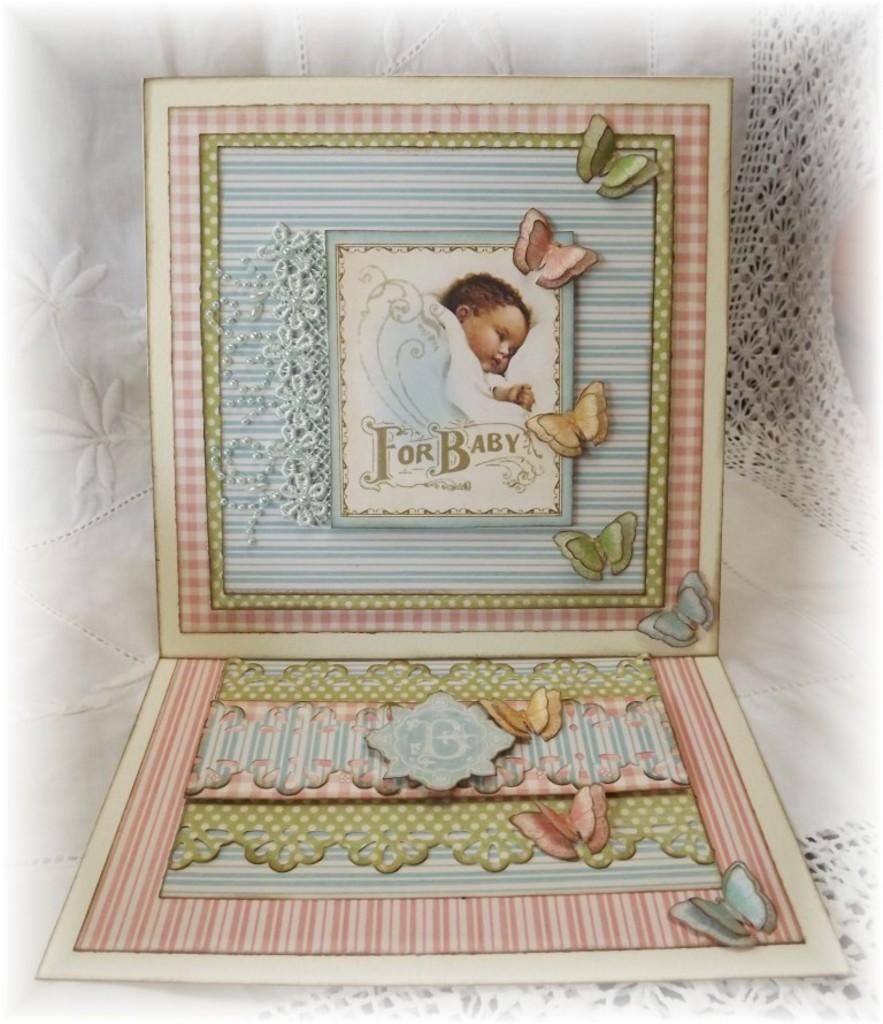<image>
Relay a brief, clear account of the picture shown. A scrapbook layout design for baby with blue and pink. 